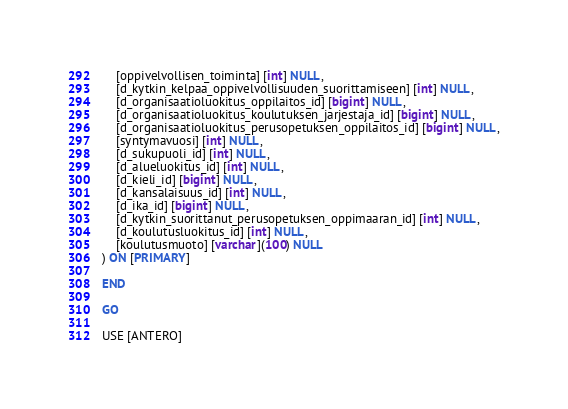<code> <loc_0><loc_0><loc_500><loc_500><_SQL_>	[oppivelvollisen_toiminta] [int] NULL,
	[d_kytkin_kelpaa_oppivelvollisuuden_suorittamiseen] [int] NULL,
	[d_organisaatioluokitus_oppilaitos_id] [bigint] NULL,
	[d_organisaatioluokitus_koulutuksen_jarjestaja_id] [bigint] NULL,
	[d_organisaatioluokitus_perusopetuksen_oppilaitos_id] [bigint] NULL,
	[syntymavuosi] [int] NULL,
	[d_sukupuoli_id] [int] NULL,
	[d_alueluokitus_id] [int] NULL,
	[d_kieli_id] [bigint] NULL,
	[d_kansalaisuus_id] [int] NULL,
	[d_ika_id] [bigint] NULL,
	[d_kytkin_suorittanut_perusopetuksen_oppimaaran_id] [int] NULL,
	[d_koulutusluokitus_id] [int] NULL,
	[koulutusmuoto] [varchar](100) NULL
) ON [PRIMARY]

END

GO

USE [ANTERO]</code> 